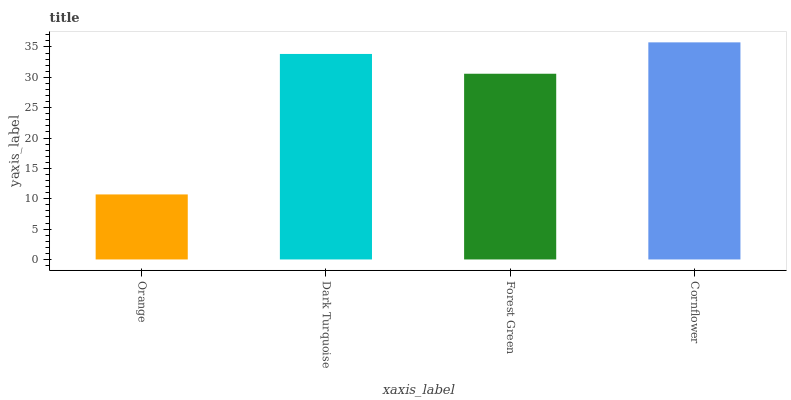Is Orange the minimum?
Answer yes or no. Yes. Is Cornflower the maximum?
Answer yes or no. Yes. Is Dark Turquoise the minimum?
Answer yes or no. No. Is Dark Turquoise the maximum?
Answer yes or no. No. Is Dark Turquoise greater than Orange?
Answer yes or no. Yes. Is Orange less than Dark Turquoise?
Answer yes or no. Yes. Is Orange greater than Dark Turquoise?
Answer yes or no. No. Is Dark Turquoise less than Orange?
Answer yes or no. No. Is Dark Turquoise the high median?
Answer yes or no. Yes. Is Forest Green the low median?
Answer yes or no. Yes. Is Orange the high median?
Answer yes or no. No. Is Orange the low median?
Answer yes or no. No. 